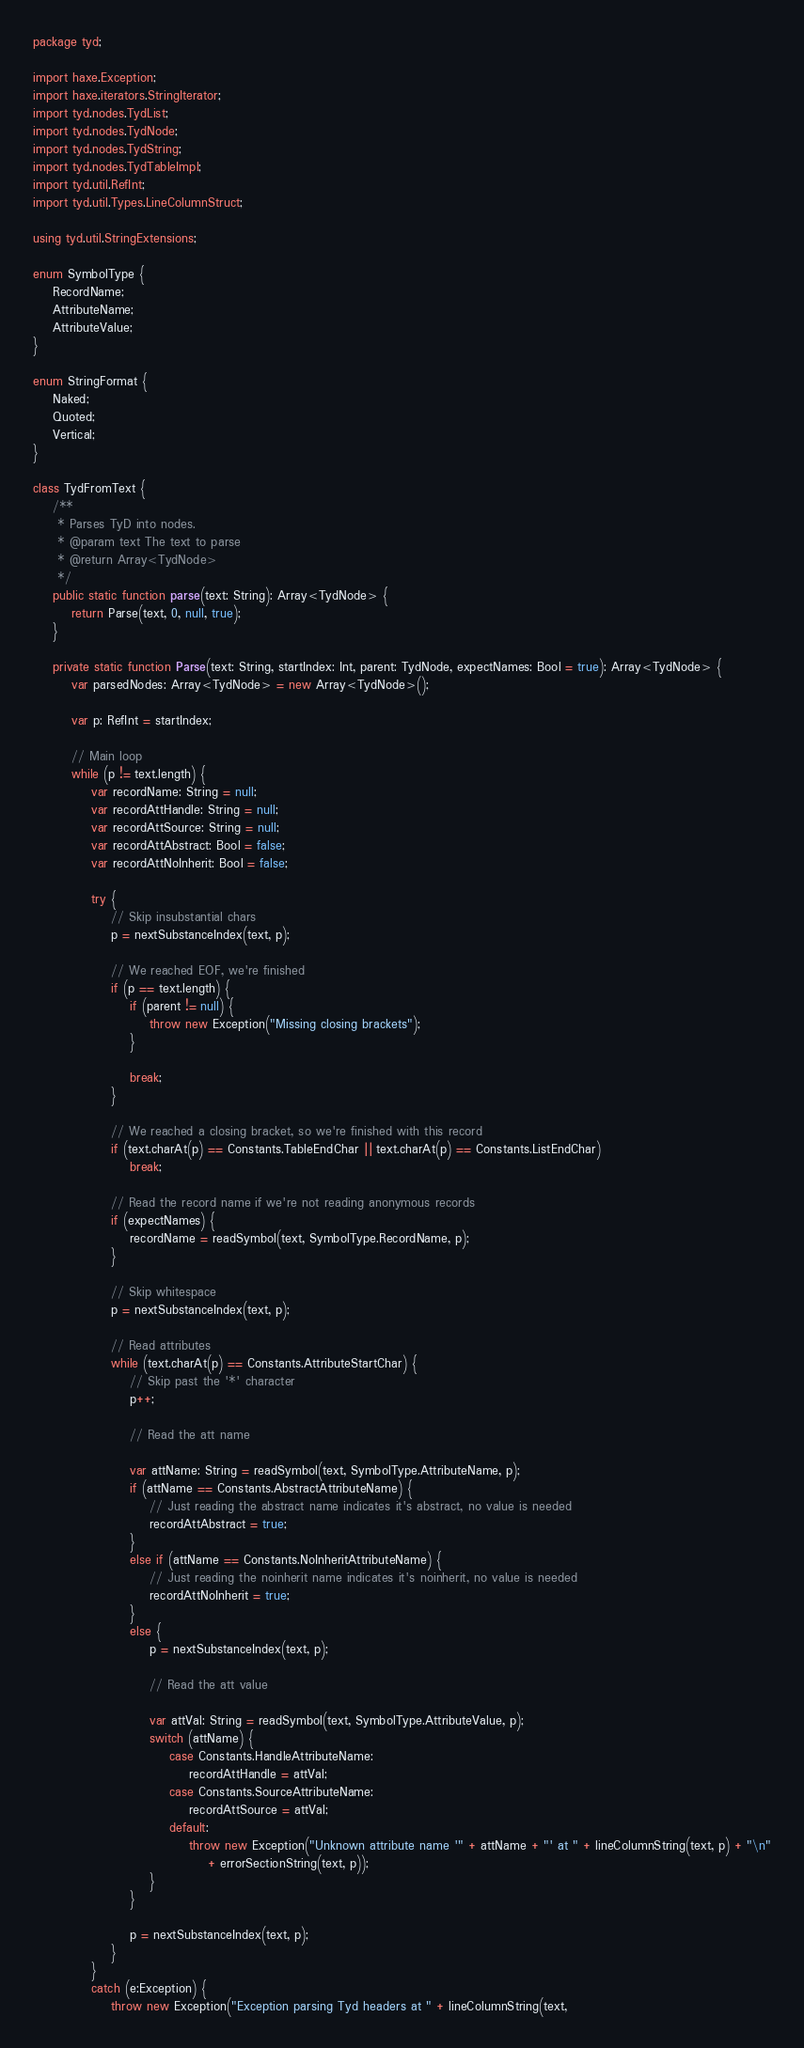<code> <loc_0><loc_0><loc_500><loc_500><_Haxe_>package tyd;

import haxe.Exception;
import haxe.iterators.StringIterator;
import tyd.nodes.TydList;
import tyd.nodes.TydNode;
import tyd.nodes.TydString;
import tyd.nodes.TydTableImpl;
import tyd.util.RefInt;
import tyd.util.Types.LineColumnStruct;

using tyd.util.StringExtensions;

enum SymbolType {
	RecordName;
	AttributeName;
	AttributeValue;
}

enum StringFormat {
	Naked;
	Quoted;
	Vertical;
}

class TydFromText {
	/**
	 * Parses TyD into nodes.
	 * @param text The text to parse
	 * @return Array<TydNode>
	 */
	public static function parse(text: String): Array<TydNode> {
		return Parse(text, 0, null, true);
	}

	private static function Parse(text: String, startIndex: Int, parent: TydNode, expectNames: Bool = true): Array<TydNode> {
		var parsedNodes: Array<TydNode> = new Array<TydNode>();

		var p: RefInt = startIndex;

		// Main loop
		while (p != text.length) {
			var recordName: String = null;
			var recordAttHandle: String = null;
			var recordAttSource: String = null;
			var recordAttAbstract: Bool = false;
			var recordAttNoInherit: Bool = false;

			try {
				// Skip insubstantial chars
				p = nextSubstanceIndex(text, p);

				// We reached EOF, we're finished
				if (p == text.length) {
					if (parent != null) {
						throw new Exception("Missing closing brackets");
					}

					break;
				}

				// We reached a closing bracket, so we're finished with this record
				if (text.charAt(p) == Constants.TableEndChar || text.charAt(p) == Constants.ListEndChar)
					break;

				// Read the record name if we're not reading anonymous records
				if (expectNames) {
					recordName = readSymbol(text, SymbolType.RecordName, p);
				}

				// Skip whitespace
				p = nextSubstanceIndex(text, p);

				// Read attributes
				while (text.charAt(p) == Constants.AttributeStartChar) {
					// Skip past the '*' character
					p++;

					// Read the att name

					var attName: String = readSymbol(text, SymbolType.AttributeName, p);
					if (attName == Constants.AbstractAttributeName) {
						// Just reading the abstract name indicates it's abstract, no value is needed
						recordAttAbstract = true;
					}
					else if (attName == Constants.NoInheritAttributeName) {
						// Just reading the noinherit name indicates it's noinherit, no value is needed
						recordAttNoInherit = true;
					}
					else {
						p = nextSubstanceIndex(text, p);

						// Read the att value

						var attVal: String = readSymbol(text, SymbolType.AttributeValue, p);
						switch (attName) {
							case Constants.HandleAttributeName:
								recordAttHandle = attVal;
							case Constants.SourceAttributeName:
								recordAttSource = attVal;
							default:
								throw new Exception("Unknown attribute name '" + attName + "' at " + lineColumnString(text, p) + "\n"
									+ errorSectionString(text, p));
						}
					}

					p = nextSubstanceIndex(text, p);
				}
			}
			catch (e:Exception) {
				throw new Exception("Exception parsing Tyd headers at " + lineColumnString(text,</code> 